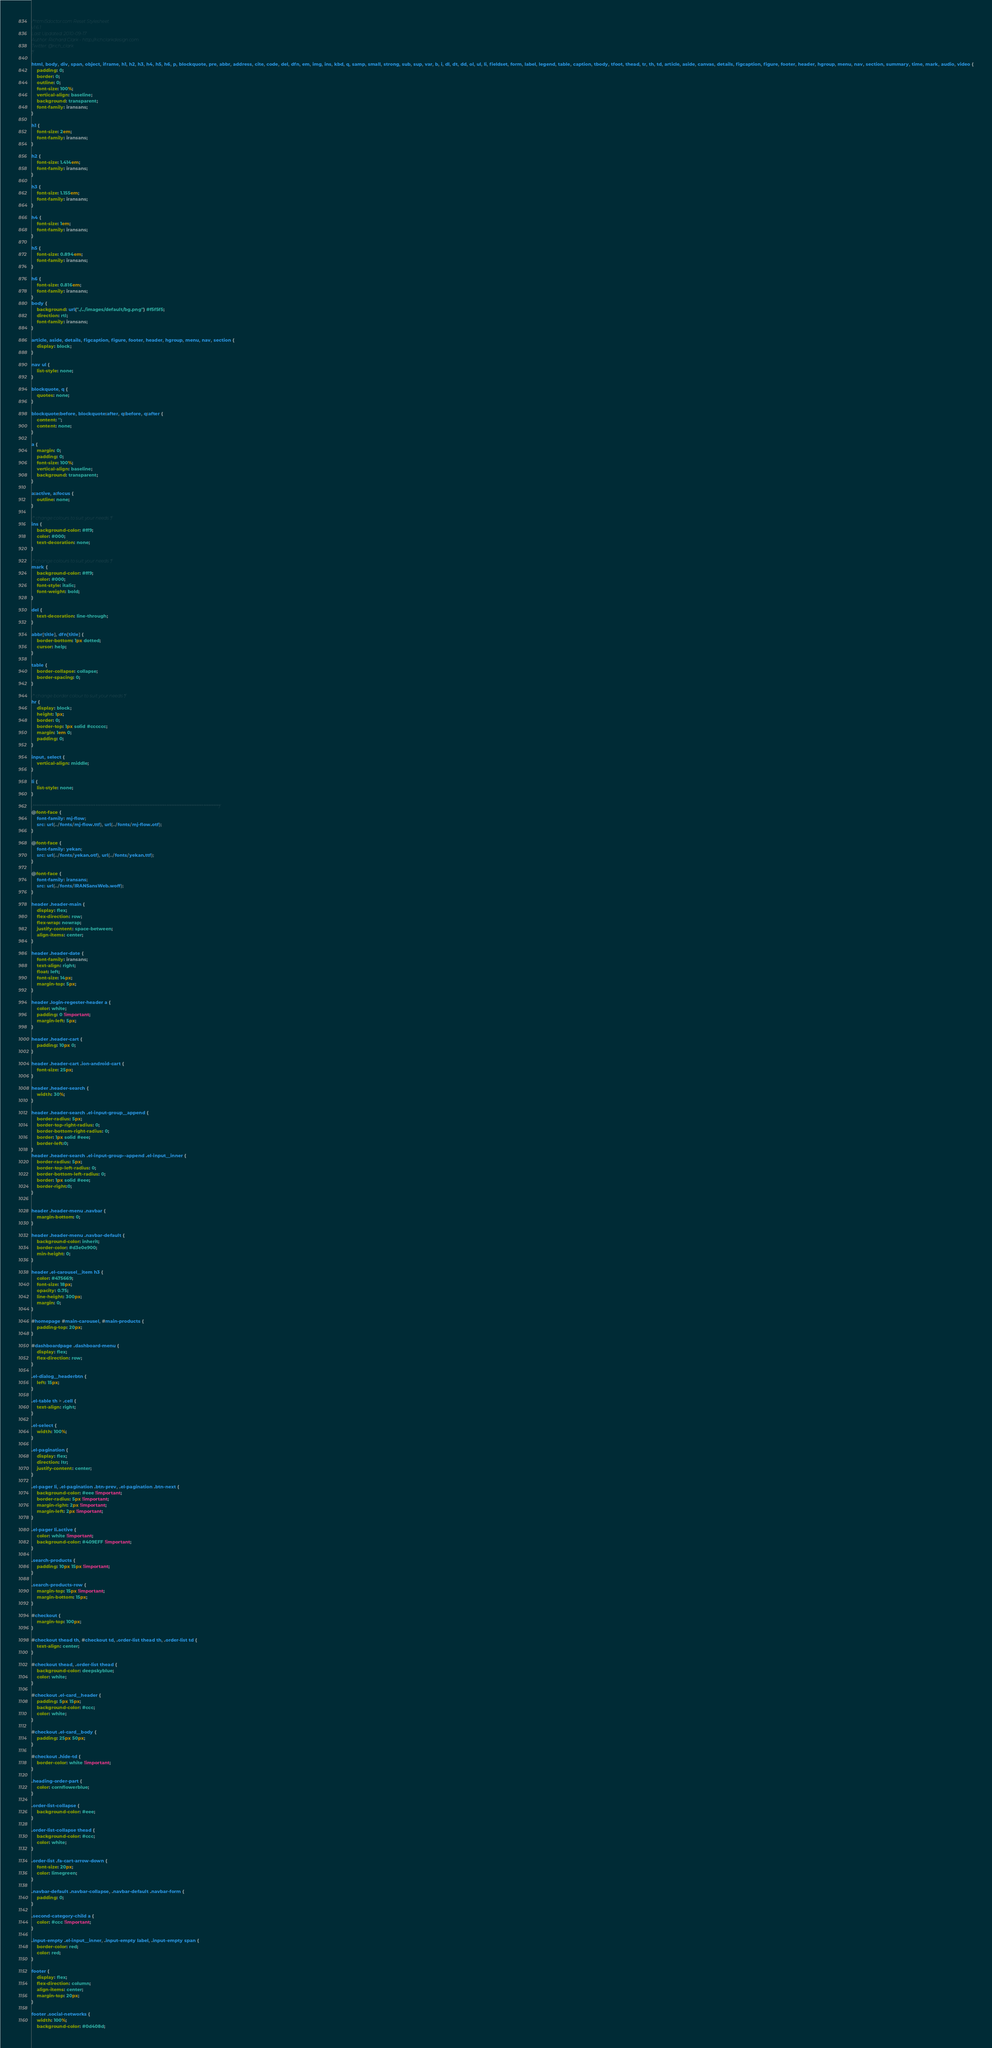Convert code to text. <code><loc_0><loc_0><loc_500><loc_500><_CSS_>/*html5doctor.com Reset Stylesheet
v1.6.1
Last Updated: 2010-09-17
Author: Richard Clark - http://richclarkdesign.com
Twitter: @rich_clark
*/

html, body, div, span, object, iframe, h1, h2, h3, h4, h5, h6, p, blockquote, pre, abbr, address, cite, code, del, dfn, em, img, ins, kbd, q, samp, small, strong, sub, sup, var, b, i, dl, dt, dd, ol, ul, li, fieldset, form, label, legend, table, caption, tbody, tfoot, thead, tr, th, td, article, aside, canvas, details, figcaption, figure, footer, header, hgroup, menu, nav, section, summary, time, mark, audio, video {
    padding: 0;
    border: 0;
    outline: 0;
    font-size: 100%;
    vertical-align: baseline;
    background: transparent;
    font-family: iransans;
}

h1 {
    font-size: 2em;
    font-family: iransans;
}

h2 {
    font-size: 1.414em;
    font-family: iransans;
}

h3 {
    font-size: 1.155em;
    font-family: iransans;
}

h4 {
    font-size: 1em;
    font-family: iransans;
}

h5 {
    font-size: 0.894em;
    font-family: iransans;
}

h6 {
    font-size: 0.816em;
    font-family: iransans;
}
body {
    background: url("./../images/default/bg.png") #f5f5f5;
    direction: rtl;
    font-family: iransans;
}

article, aside, details, figcaption, figure, footer, header, hgroup, menu, nav, section {
    display: block;
}

nav ul {
    list-style: none;
}

blockquote, q {
    quotes: none;
}

blockquote:before, blockquote:after, q:before, q:after {
    content: '';
    content: none;
}

a {
    margin: 0;
    padding: 0;
    font-size: 100%;
    vertical-align: baseline;
    background: transparent;
}

a:active, a:focus {
    outline: none;
}

/* change colours to suit your needs */
ins {
    background-color: #ff9;
    color: #000;
    text-decoration: none;
}

/* change colours to suit your needs */
mark {
    background-color: #ff9;
    color: #000;
    font-style: italic;
    font-weight: bold;
}

del {
    text-decoration: line-through;
}

abbr[title], dfn[title] {
    border-bottom: 1px dotted;
    cursor: help;
}

table {
    border-collapse: collapse;
    border-spacing: 0;
}

/* change border colour to suit your needs */
hr {
    display: block;
    height: 1px;
    border: 0;
    border-top: 1px solid #cccccc;
    margin: 1em 0;
    padding: 0;
}

input, select {
    vertical-align: middle;
}

li {
    list-style: none;
}

/***************************************************************************************************************/
@font-face {
    font-family: mj-flow;
    src: url(../fonts/mj-flow.ttf), url(../fonts/mj-flow.otf);
}

@font-face {
    font-family: yekan;
    src: url(../fonts/yekan.otf), url(../fonts/yekan.ttf);
}

@font-face {
    font-family: iransans;
    src: url(../fonts/IRANSansWeb.woff);
}

header .header-main {
    display: flex;
    flex-direction: row;
    flex-wrap: nowrap;
    justify-content: space-between;
    align-items: center;
}

header .header-date {
    font-family: iransans;
    text-align: right;
    float: left;
    font-size: 14px;
    margin-top: 5px;
}

header .login-regester-header a {
    color: white;
    padding: 0 !important;
    margin-left: 5px;
}

header .header-cart {
    padding: 10px 0;
}

header .header-cart .ion-android-cart {
    font-size: 25px;
}

header .header-search {
    width: 30%;
}

header .header-search .el-input-group__append {
    border-radius: 5px;
    border-top-right-radius: 0;
    border-bottom-right-radius: 0;
    border: 1px solid #eee;
    border-left:0;
}
header .header-search .el-input-group--append .el-input__inner {
    border-radius: 5px;
    border-top-left-radius: 0;
    border-bottom-left-radius: 0;
    border: 1px solid #eee;
    border-right:0;
}


header .header-menu .navbar {
    margin-bottom: 0;
}

header .header-menu .navbar-default {
    background-color: inherit;
    border-color: #d3e0e900;
    min-height: 0;
}

header .el-carousel__item h3 {
    color: #475669;
    font-size: 18px;
    opacity: 0.75;
    line-height: 300px;
    margin: 0;
}

#homepage #main-carousel, #main-products {
    padding-top: 20px;
}

#dashboardpage .dashboard-menu {
    display: flex;
    flex-direction: row;
}

.el-dialog__headerbtn {
    left: 15px;
}

.el-table th > .cell {
    text-align: right;
}

.el-select {
    width: 100%;
}

.el-pagination {
    display: flex;
    direction: ltr;
    justify-content: center;
}

.el-pager li, .el-pagination .btn-prev, .el-pagination .btn-next {
    background-color: #eee !important;
    border-radius: 5px !important;
    margin-right: 2px !important;
    margin-left: 2px !important;
}

.el-pager li.active {
    color: white !important;
    background-color: #409EFF !important;
}

.search-products {
    padding: 10px 15px !important;
}

.search-products-row {
    margin-top: 15px !important;
    margin-bottom: 15px;
}

#checkout {
    margin-top: 100px;
}

#checkout thead th, #checkout td, .order-list thead th, .order-list td {
    text-align: center;
}

#checkout thead, .order-list thead {
    background-color: deepskyblue;
    color: white;
}

#checkout .el-card__header {
    padding: 5px 15px;
    background-color: #ccc;
    color: white;
}

#checkout .el-card__body {
    padding: 25px 50px;
}

#checkout .hide-td {
    border-color: white !important;
}

.heading-order-part {
    color: cornflowerblue;
}

.order-list-collapse {
    background-color: #eee;
}

.order-list-collapse thead {
    background-color: #ccc;
    color: white;
}

.order-list .fa-cart-arrow-down {
    font-size: 20px;
    color: limegreen;
}

.navbar-default .navbar-collapse, .navbar-default .navbar-form {
    padding: 0;
}

.second-category-child a {
    color: #ccc !important;
}

.input-empty .el-input__inner, .input-empty label, .input-empty span {
    border-color: red;
    color: red;
}

footer {
    display: flex;
    flex-direction: column;
    align-items: center;
    margin-top: 20px;
}

footer .social-networks {
    width: 100%;
    background-color: #0d408d;</code> 